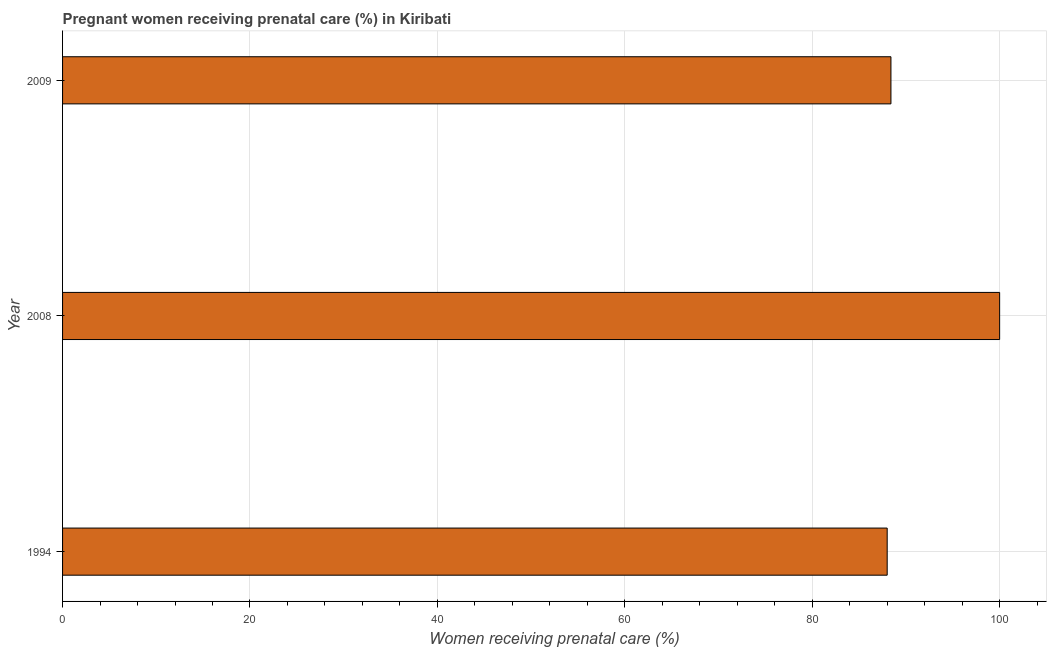Does the graph contain any zero values?
Keep it short and to the point. No. What is the title of the graph?
Your response must be concise. Pregnant women receiving prenatal care (%) in Kiribati. What is the label or title of the X-axis?
Give a very brief answer. Women receiving prenatal care (%). What is the percentage of pregnant women receiving prenatal care in 2008?
Your response must be concise. 100. Across all years, what is the minimum percentage of pregnant women receiving prenatal care?
Offer a very short reply. 88. In which year was the percentage of pregnant women receiving prenatal care maximum?
Your response must be concise. 2008. What is the sum of the percentage of pregnant women receiving prenatal care?
Provide a succinct answer. 276.4. What is the average percentage of pregnant women receiving prenatal care per year?
Provide a succinct answer. 92.13. What is the median percentage of pregnant women receiving prenatal care?
Provide a succinct answer. 88.4. In how many years, is the percentage of pregnant women receiving prenatal care greater than 36 %?
Your response must be concise. 3. Do a majority of the years between 2008 and 1994 (inclusive) have percentage of pregnant women receiving prenatal care greater than 8 %?
Make the answer very short. No. What is the ratio of the percentage of pregnant women receiving prenatal care in 2008 to that in 2009?
Ensure brevity in your answer.  1.13. Is the difference between the percentage of pregnant women receiving prenatal care in 2008 and 2009 greater than the difference between any two years?
Your answer should be very brief. No. What is the difference between the highest and the second highest percentage of pregnant women receiving prenatal care?
Provide a succinct answer. 11.6. Is the sum of the percentage of pregnant women receiving prenatal care in 1994 and 2008 greater than the maximum percentage of pregnant women receiving prenatal care across all years?
Your response must be concise. Yes. What is the difference between the highest and the lowest percentage of pregnant women receiving prenatal care?
Offer a terse response. 12. How many bars are there?
Give a very brief answer. 3. Are all the bars in the graph horizontal?
Offer a terse response. Yes. How many years are there in the graph?
Give a very brief answer. 3. What is the Women receiving prenatal care (%) of 2008?
Your response must be concise. 100. What is the Women receiving prenatal care (%) of 2009?
Ensure brevity in your answer.  88.4. What is the difference between the Women receiving prenatal care (%) in 1994 and 2009?
Provide a short and direct response. -0.4. What is the difference between the Women receiving prenatal care (%) in 2008 and 2009?
Your answer should be very brief. 11.6. What is the ratio of the Women receiving prenatal care (%) in 2008 to that in 2009?
Provide a short and direct response. 1.13. 